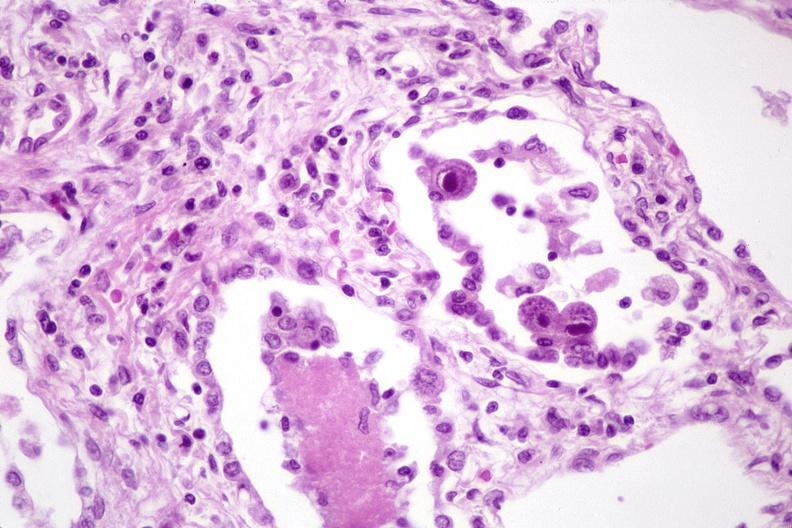what is present?
Answer the question using a single word or phrase. Respiratory 